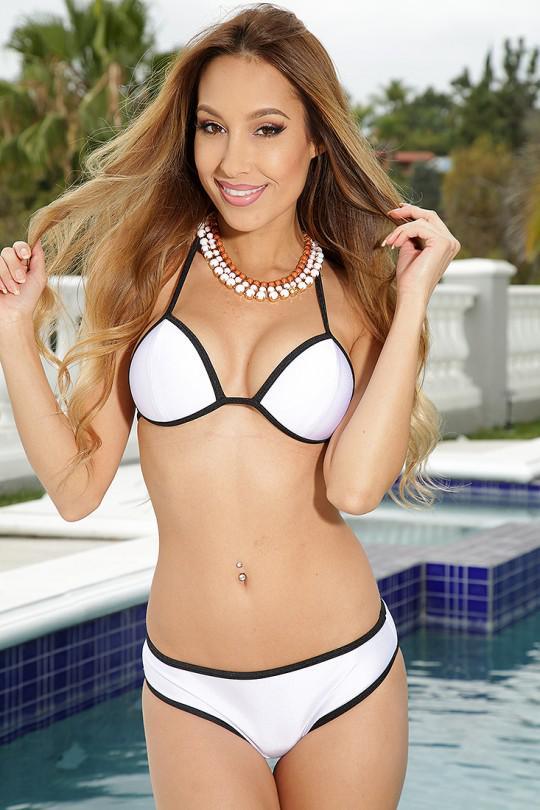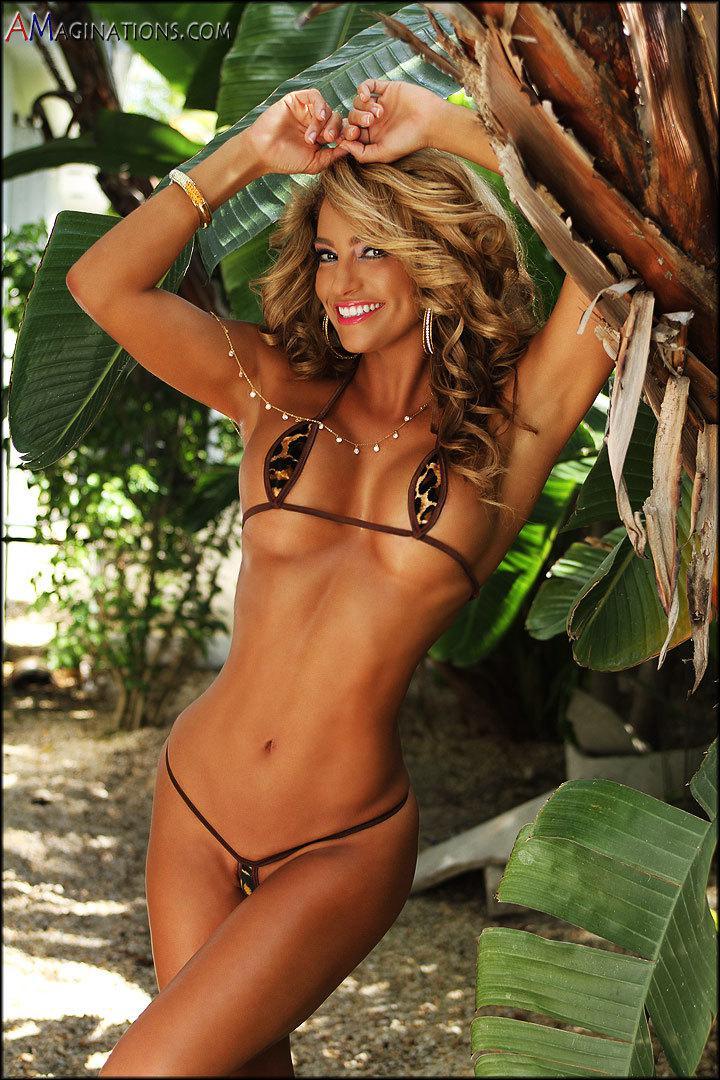The first image is the image on the left, the second image is the image on the right. For the images shown, is this caption "In 1 of the images, 1 girl is holding her hands above her head." true? Answer yes or no. Yes. The first image is the image on the left, the second image is the image on the right. Examine the images to the left and right. Is the description "An image shows a girl in a nearly all-white bikini in front of a pool." accurate? Answer yes or no. Yes. 